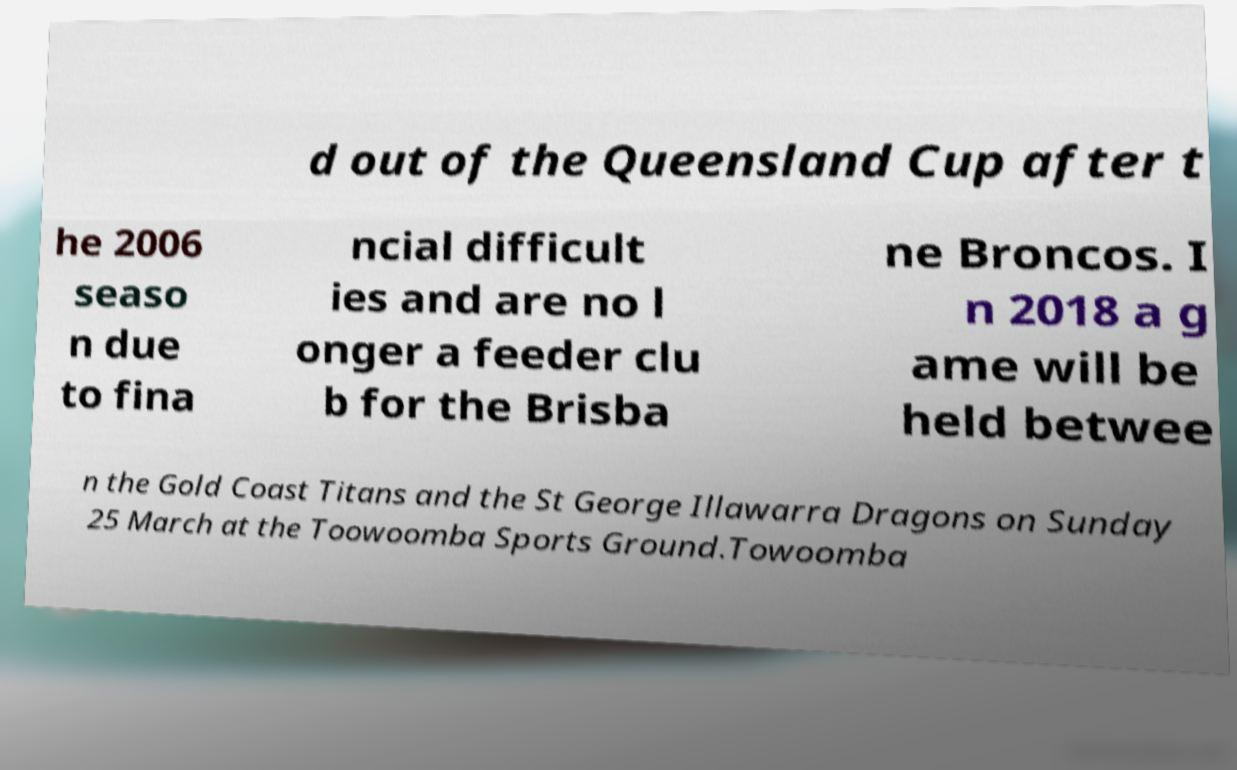Could you assist in decoding the text presented in this image and type it out clearly? d out of the Queensland Cup after t he 2006 seaso n due to fina ncial difficult ies and are no l onger a feeder clu b for the Brisba ne Broncos. I n 2018 a g ame will be held betwee n the Gold Coast Titans and the St George Illawarra Dragons on Sunday 25 March at the Toowoomba Sports Ground.Towoomba 